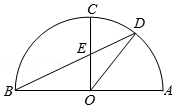Given that angle DEC is 65 degrees, what can we deduce about the other angles in triangle DEC? Triangle DEC is not a right triangle since angle DEC is 65 degrees, and angle ECD is also 65 degrees by symmetry of the isosceles triangle. This leaves the remaining angle, CDE, to be a total of 180 degrees minus the sum of DEC and ECD, which equals 180 - 130 = 50 degrees. 